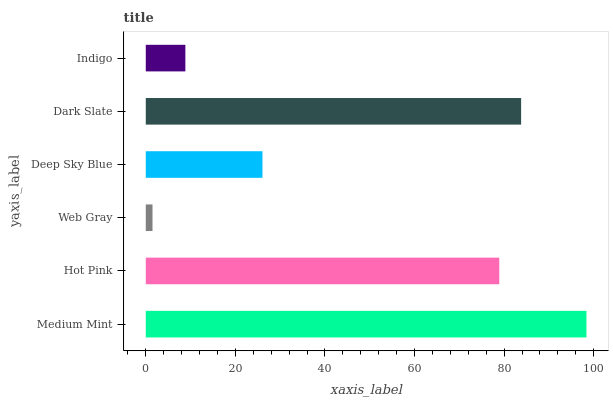Is Web Gray the minimum?
Answer yes or no. Yes. Is Medium Mint the maximum?
Answer yes or no. Yes. Is Hot Pink the minimum?
Answer yes or no. No. Is Hot Pink the maximum?
Answer yes or no. No. Is Medium Mint greater than Hot Pink?
Answer yes or no. Yes. Is Hot Pink less than Medium Mint?
Answer yes or no. Yes. Is Hot Pink greater than Medium Mint?
Answer yes or no. No. Is Medium Mint less than Hot Pink?
Answer yes or no. No. Is Hot Pink the high median?
Answer yes or no. Yes. Is Deep Sky Blue the low median?
Answer yes or no. Yes. Is Web Gray the high median?
Answer yes or no. No. Is Medium Mint the low median?
Answer yes or no. No. 